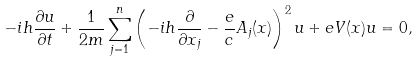<formula> <loc_0><loc_0><loc_500><loc_500>- i h \frac { \partial u } { \partial t } + \frac { 1 } { 2 m } \sum _ { j = 1 } ^ { n } \left ( - i h \frac { \partial } { \partial x _ { j } } - \frac { e } { c } A _ { j } ( x ) \right ) ^ { 2 } u + e V ( x ) u = 0 ,</formula> 